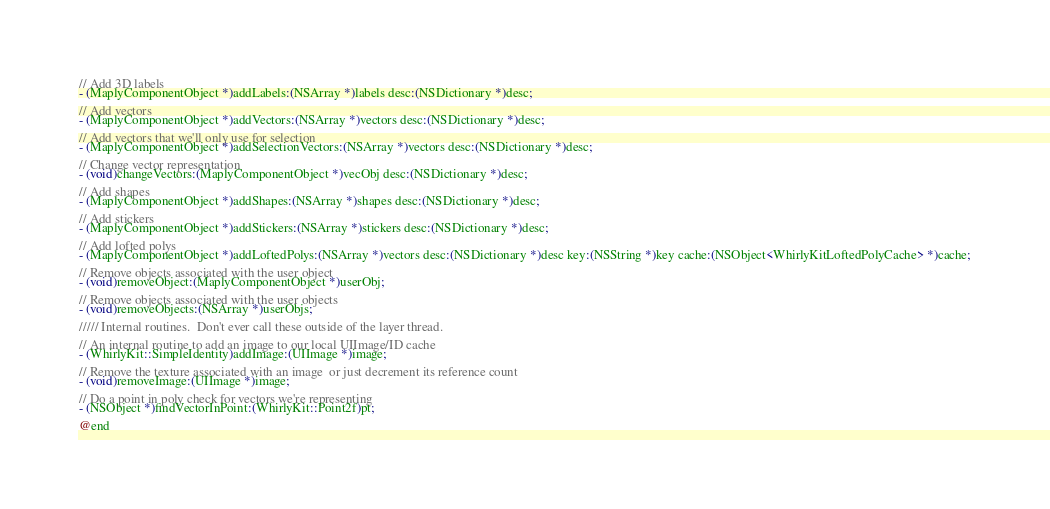Convert code to text. <code><loc_0><loc_0><loc_500><loc_500><_C_>// Add 3D labels
- (MaplyComponentObject *)addLabels:(NSArray *)labels desc:(NSDictionary *)desc;

// Add vectors
- (MaplyComponentObject *)addVectors:(NSArray *)vectors desc:(NSDictionary *)desc;

// Add vectors that we'll only use for selection
- (MaplyComponentObject *)addSelectionVectors:(NSArray *)vectors desc:(NSDictionary *)desc;

// Change vector representation
- (void)changeVectors:(MaplyComponentObject *)vecObj desc:(NSDictionary *)desc;

// Add shapes
- (MaplyComponentObject *)addShapes:(NSArray *)shapes desc:(NSDictionary *)desc;

// Add stickers
- (MaplyComponentObject *)addStickers:(NSArray *)stickers desc:(NSDictionary *)desc;

// Add lofted polys
- (MaplyComponentObject *)addLoftedPolys:(NSArray *)vectors desc:(NSDictionary *)desc key:(NSString *)key cache:(NSObject<WhirlyKitLoftedPolyCache> *)cache;

// Remove objects associated with the user object
- (void)removeObject:(MaplyComponentObject *)userObj;

// Remove objects associated with the user objects
- (void)removeObjects:(NSArray *)userObjs;

///// Internal routines.  Don't ever call these outside of the layer thread.

// An internal routine to add an image to our local UIImage/ID cache
- (WhirlyKit::SimpleIdentity)addImage:(UIImage *)image;

// Remove the texture associated with an image  or just decrement its reference count
- (void)removeImage:(UIImage *)image;

// Do a point in poly check for vectors we're representing
- (NSObject *)findVectorInPoint:(WhirlyKit::Point2f)pt;

@end
</code> 